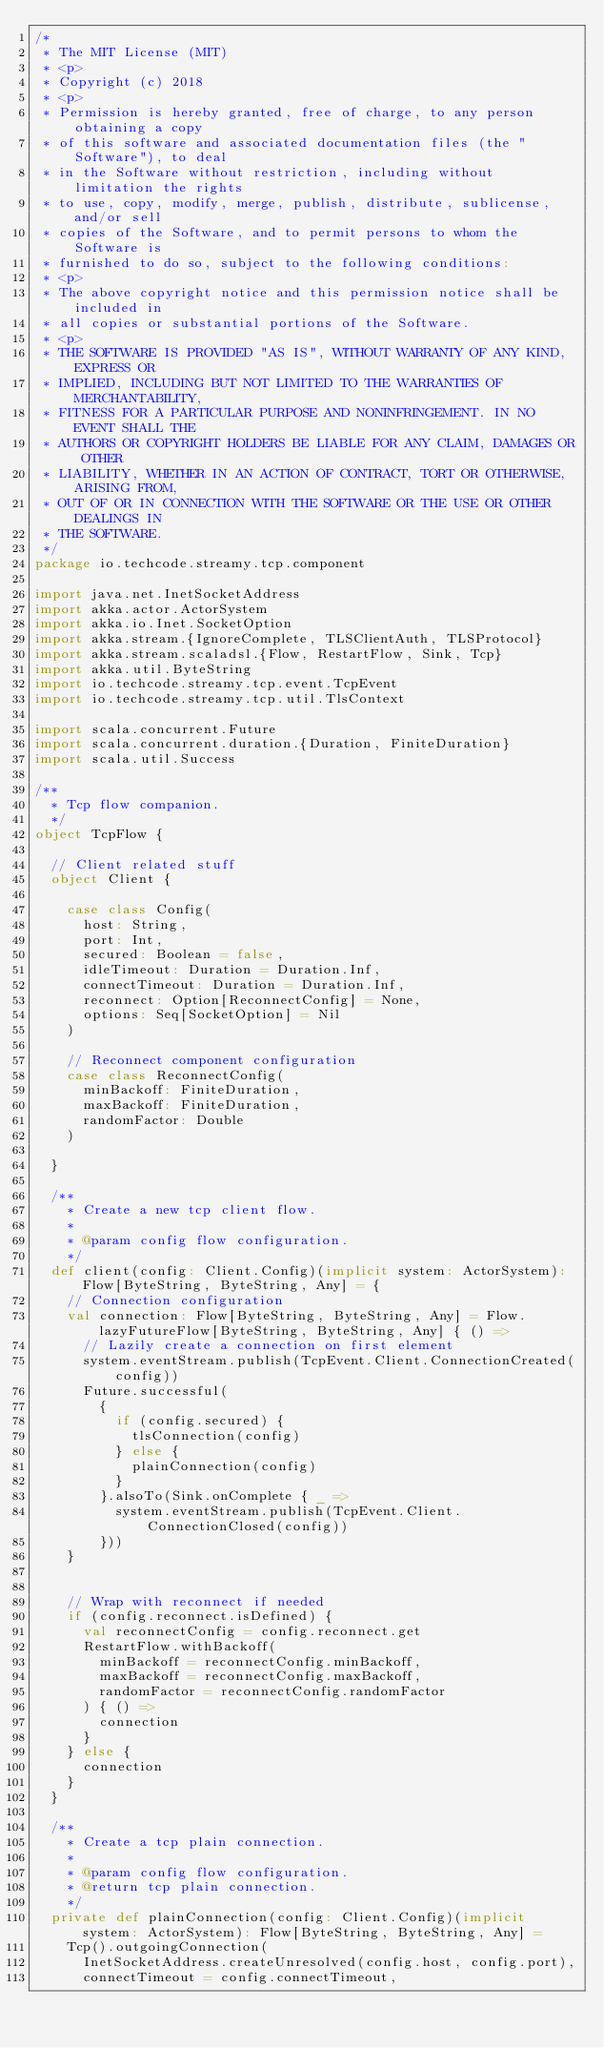Convert code to text. <code><loc_0><loc_0><loc_500><loc_500><_Scala_>/*
 * The MIT License (MIT)
 * <p>
 * Copyright (c) 2018
 * <p>
 * Permission is hereby granted, free of charge, to any person obtaining a copy
 * of this software and associated documentation files (the "Software"), to deal
 * in the Software without restriction, including without limitation the rights
 * to use, copy, modify, merge, publish, distribute, sublicense, and/or sell
 * copies of the Software, and to permit persons to whom the Software is
 * furnished to do so, subject to the following conditions:
 * <p>
 * The above copyright notice and this permission notice shall be included in
 * all copies or substantial portions of the Software.
 * <p>
 * THE SOFTWARE IS PROVIDED "AS IS", WITHOUT WARRANTY OF ANY KIND, EXPRESS OR
 * IMPLIED, INCLUDING BUT NOT LIMITED TO THE WARRANTIES OF MERCHANTABILITY,
 * FITNESS FOR A PARTICULAR PURPOSE AND NONINFRINGEMENT. IN NO EVENT SHALL THE
 * AUTHORS OR COPYRIGHT HOLDERS BE LIABLE FOR ANY CLAIM, DAMAGES OR OTHER
 * LIABILITY, WHETHER IN AN ACTION OF CONTRACT, TORT OR OTHERWISE, ARISING FROM,
 * OUT OF OR IN CONNECTION WITH THE SOFTWARE OR THE USE OR OTHER DEALINGS IN
 * THE SOFTWARE.
 */
package io.techcode.streamy.tcp.component

import java.net.InetSocketAddress
import akka.actor.ActorSystem
import akka.io.Inet.SocketOption
import akka.stream.{IgnoreComplete, TLSClientAuth, TLSProtocol}
import akka.stream.scaladsl.{Flow, RestartFlow, Sink, Tcp}
import akka.util.ByteString
import io.techcode.streamy.tcp.event.TcpEvent
import io.techcode.streamy.tcp.util.TlsContext

import scala.concurrent.Future
import scala.concurrent.duration.{Duration, FiniteDuration}
import scala.util.Success

/**
  * Tcp flow companion.
  */
object TcpFlow {

  // Client related stuff
  object Client {

    case class Config(
      host: String,
      port: Int,
      secured: Boolean = false,
      idleTimeout: Duration = Duration.Inf,
      connectTimeout: Duration = Duration.Inf,
      reconnect: Option[ReconnectConfig] = None,
      options: Seq[SocketOption] = Nil
    )

    // Reconnect component configuration
    case class ReconnectConfig(
      minBackoff: FiniteDuration,
      maxBackoff: FiniteDuration,
      randomFactor: Double
    )

  }

  /**
    * Create a new tcp client flow.
    *
    * @param config flow configuration.
    */
  def client(config: Client.Config)(implicit system: ActorSystem): Flow[ByteString, ByteString, Any] = {
    // Connection configuration
    val connection: Flow[ByteString, ByteString, Any] = Flow.lazyFutureFlow[ByteString, ByteString, Any] { () =>
      // Lazily create a connection on first element
      system.eventStream.publish(TcpEvent.Client.ConnectionCreated(config))
      Future.successful(
        {
          if (config.secured) {
            tlsConnection(config)
          } else {
            plainConnection(config)
          }
        }.alsoTo(Sink.onComplete { _ =>
          system.eventStream.publish(TcpEvent.Client.ConnectionClosed(config))
        }))
    }


    // Wrap with reconnect if needed
    if (config.reconnect.isDefined) {
      val reconnectConfig = config.reconnect.get
      RestartFlow.withBackoff(
        minBackoff = reconnectConfig.minBackoff,
        maxBackoff = reconnectConfig.maxBackoff,
        randomFactor = reconnectConfig.randomFactor
      ) { () =>
        connection
      }
    } else {
      connection
    }
  }

  /**
    * Create a tcp plain connection.
    *
    * @param config flow configuration.
    * @return tcp plain connection.
    */
  private def plainConnection(config: Client.Config)(implicit system: ActorSystem): Flow[ByteString, ByteString, Any] =
    Tcp().outgoingConnection(
      InetSocketAddress.createUnresolved(config.host, config.port),
      connectTimeout = config.connectTimeout,</code> 